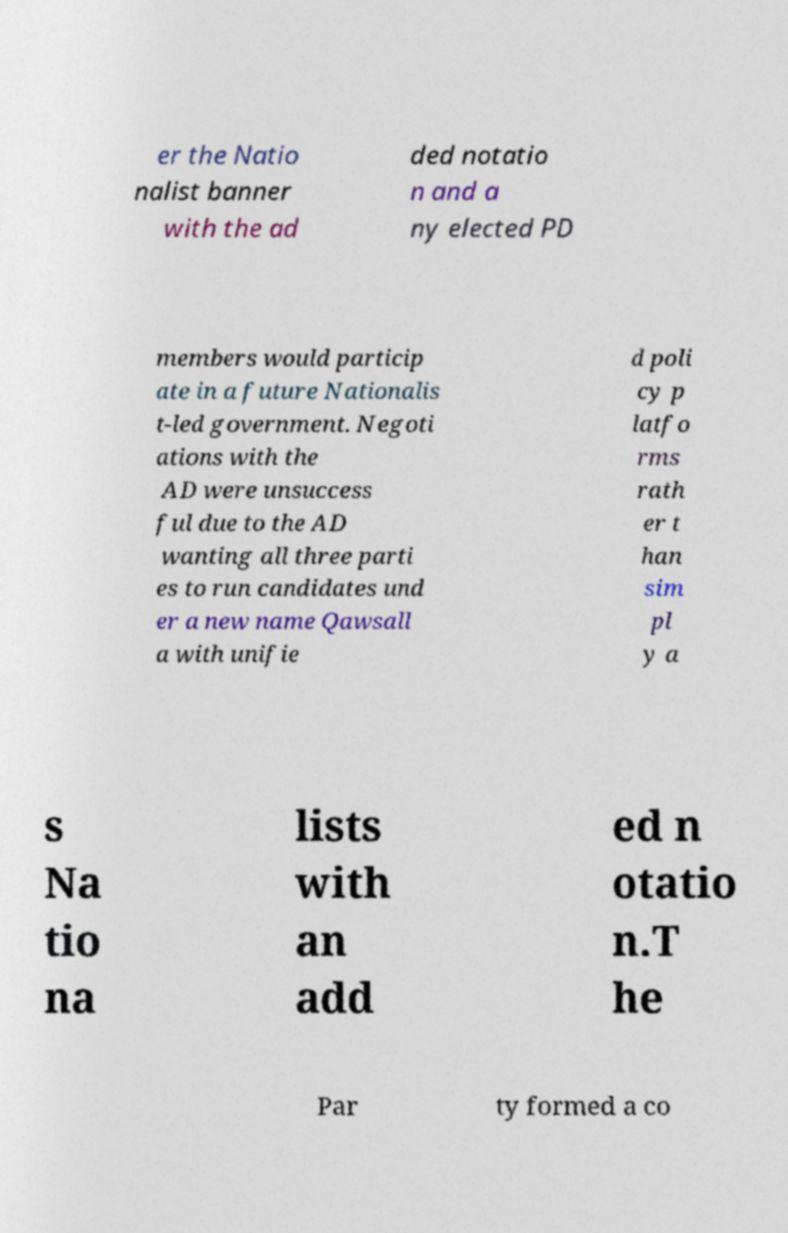What messages or text are displayed in this image? I need them in a readable, typed format. er the Natio nalist banner with the ad ded notatio n and a ny elected PD members would particip ate in a future Nationalis t-led government. Negoti ations with the AD were unsuccess ful due to the AD wanting all three parti es to run candidates und er a new name Qawsall a with unifie d poli cy p latfo rms rath er t han sim pl y a s Na tio na lists with an add ed n otatio n.T he Par ty formed a co 